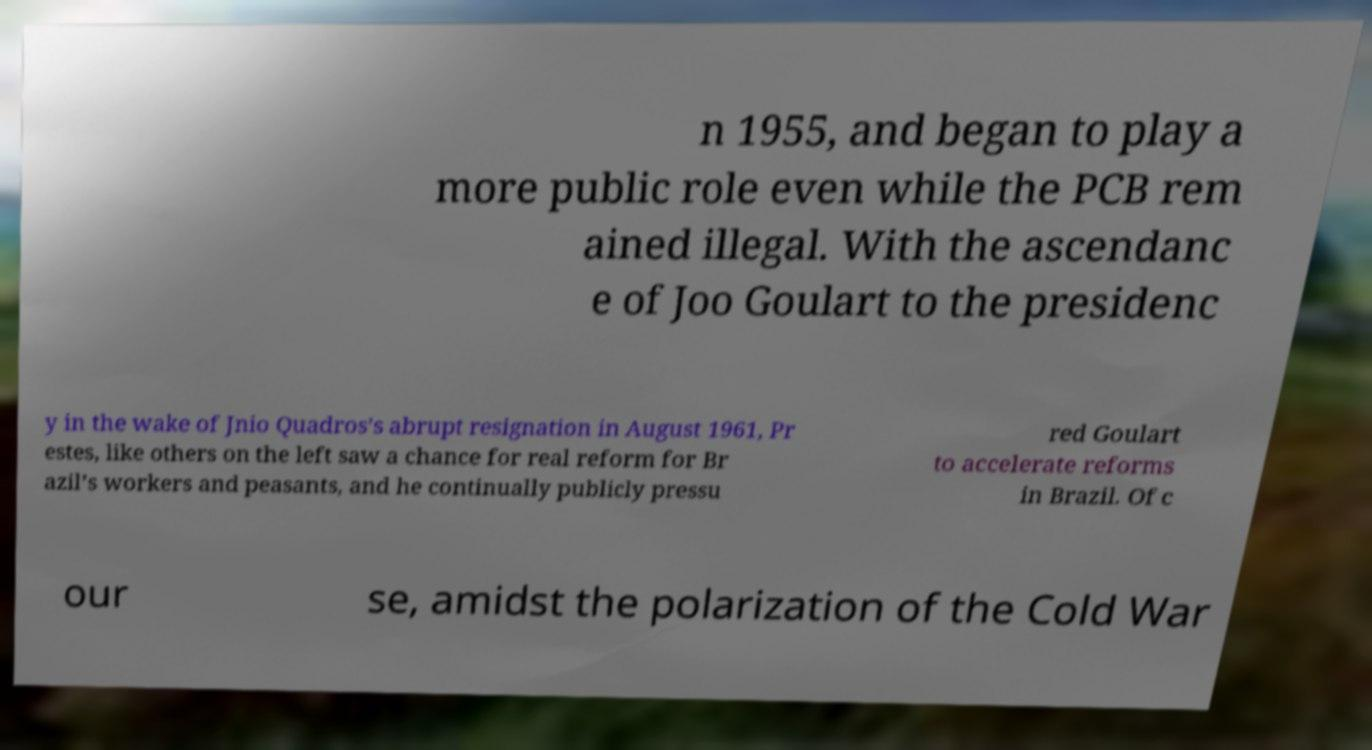Can you accurately transcribe the text from the provided image for me? n 1955, and began to play a more public role even while the PCB rem ained illegal. With the ascendanc e of Joo Goulart to the presidenc y in the wake of Jnio Quadros’s abrupt resignation in August 1961, Pr estes, like others on the left saw a chance for real reform for Br azil’s workers and peasants, and he continually publicly pressu red Goulart to accelerate reforms in Brazil. Of c our se, amidst the polarization of the Cold War 